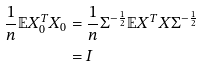<formula> <loc_0><loc_0><loc_500><loc_500>\frac { 1 } { n } \mathbb { E } X _ { 0 } ^ { T } X _ { 0 } & = \frac { 1 } { n } \Sigma ^ { - \frac { 1 } { 2 } } \mathbb { E } X ^ { T } X \Sigma ^ { - \frac { 1 } { 2 } } \\ & = I</formula> 